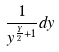<formula> <loc_0><loc_0><loc_500><loc_500>\frac { 1 } { y ^ { \frac { Y } { 2 } + 1 } } d y</formula> 